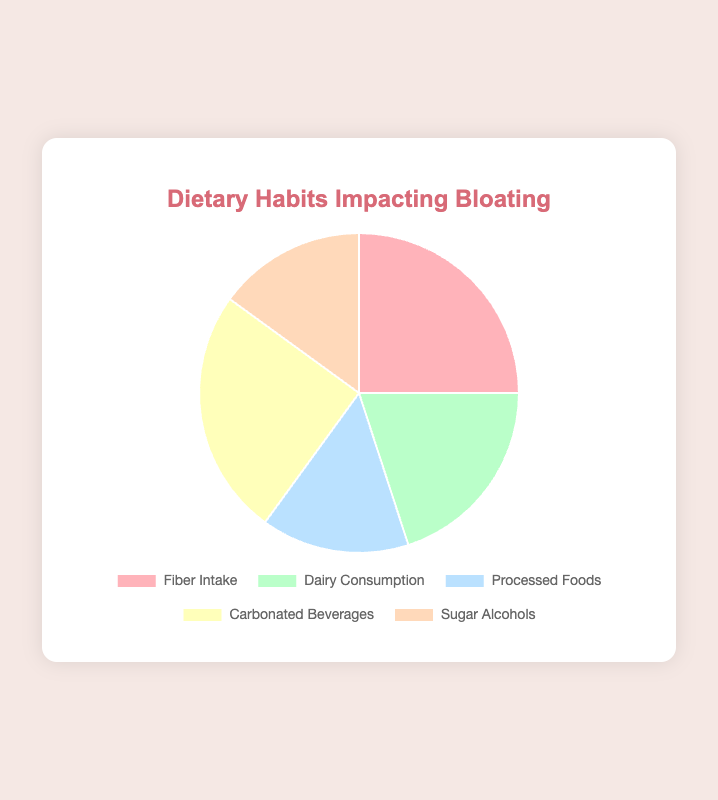What percentage of the pie chart is represented by Carbonated Beverages? The slice labeled "Carbonated Beverages" represents 25% of the pie chart, which is directly stated in the legend and the dataset.
Answer: 25% Which two categories have an equal percentage of impact on bloating? Both "Fiber Intake" and "Carbonated Beverages" have the same impact, each contributing 25% to the bloating issue.
Answer: Fiber Intake and Carbonated Beverages How much more impactful is Fiber Intake compared to Dairy Consumption? Fiber Intake is 25% while Dairy Consumption is 20%. To find the difference, subtract the smaller percentage from the larger one: 25% - 20% = 5%.
Answer: 5% Which category has the smallest impact on bloating? Both "Processed Foods" and "Sugar Alcohols" have the smallest impact, each contributing 15%.
Answer: Processed Foods and Sugar Alcohols What's the total percentage impact of Processed Foods and Sugar Alcohols combined? Add the percentages of Processed Foods (15%) and Sugar Alcohols (15%): 15% + 15% = 30%.
Answer: 30% What is the most common color representing dietary habits impacting bloating on the chart? The chart uses different colors, and the pie slices are either red, green, blue, yellow, or orange. The color does not repeat for any other category.
Answer: No color repeats How many more percentage points is Fiber Intake compared to Processed Foods? Fiber Intake is 25%, and Processed Foods is 15%. Subtract the smaller percentage from the larger one: 25% - 15% = 10%.
Answer: 10% Which category is represented by the light blue color? Processed Foods is represented by the light blue color in the chart.
Answer: Processed Foods If Dairy Consumption and Carbonated Beverages were combined into one category, what would their total percentage be? Add the percentages of Dairy Consumption (20%) and Carbonated Beverages (25%): 20% + 25% = 45%.
Answer: 45% What is the sum of the percentages of categories that have an impact of 20% or more? Add the percentages of Fiber Intake (25%), Dairy Consumption (20%), and Carbonated Beverages (25%): 25% + 20% + 25% = 70%.
Answer: 70% 